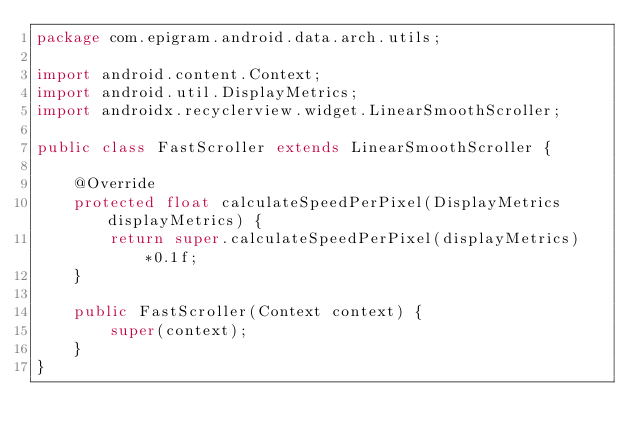<code> <loc_0><loc_0><loc_500><loc_500><_Java_>package com.epigram.android.data.arch.utils;

import android.content.Context;
import android.util.DisplayMetrics;
import androidx.recyclerview.widget.LinearSmoothScroller;

public class FastScroller extends LinearSmoothScroller {

    @Override
    protected float calculateSpeedPerPixel(DisplayMetrics displayMetrics) {
        return super.calculateSpeedPerPixel(displayMetrics)*0.1f;
    }

    public FastScroller(Context context) {
        super(context);
    }
}


</code> 